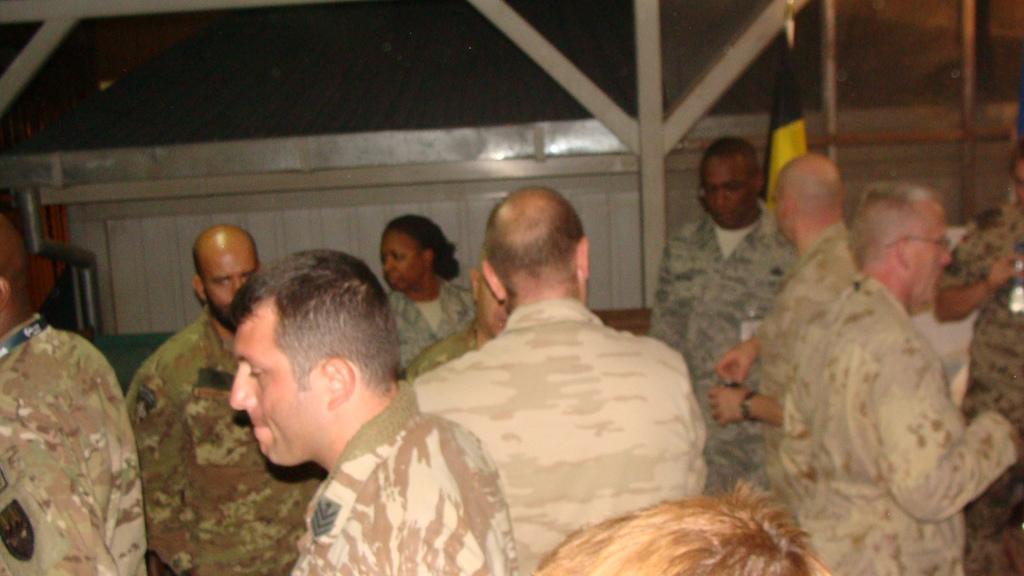Can you describe this image briefly? In this image we can see people. In the background we can see wall, flag, and an object. 